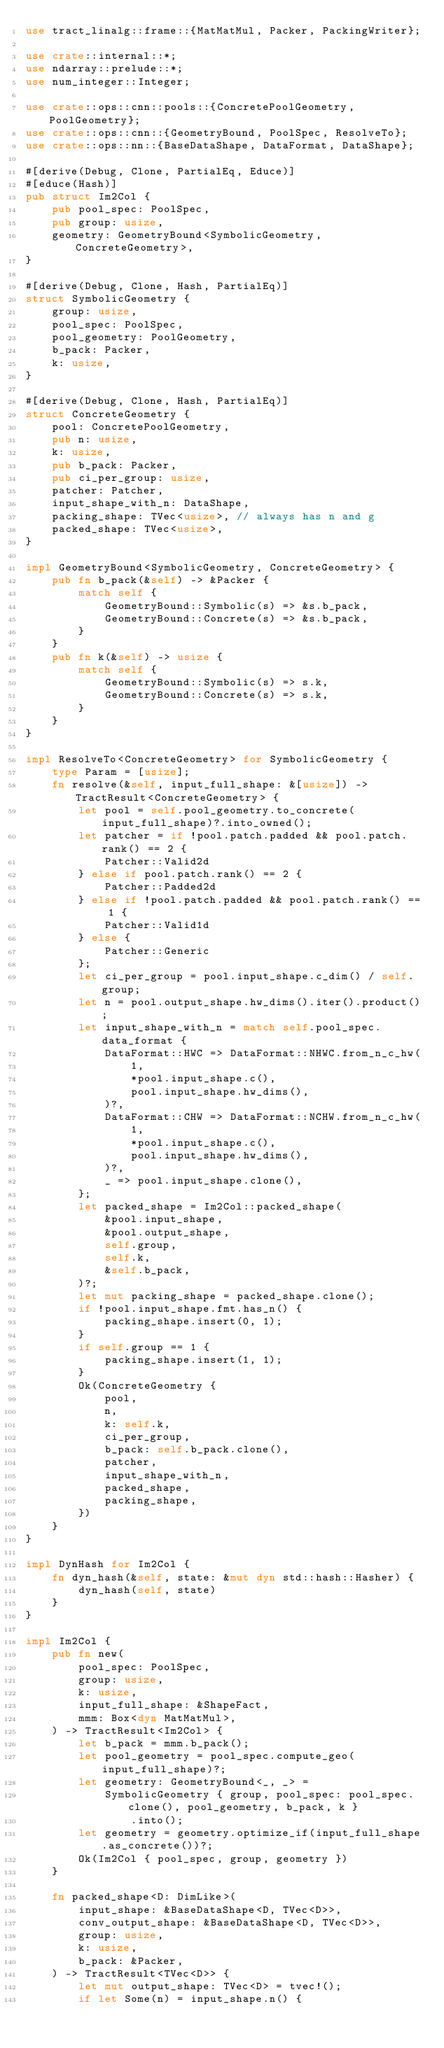Convert code to text. <code><loc_0><loc_0><loc_500><loc_500><_Rust_>use tract_linalg::frame::{MatMatMul, Packer, PackingWriter};

use crate::internal::*;
use ndarray::prelude::*;
use num_integer::Integer;

use crate::ops::cnn::pools::{ConcretePoolGeometry, PoolGeometry};
use crate::ops::cnn::{GeometryBound, PoolSpec, ResolveTo};
use crate::ops::nn::{BaseDataShape, DataFormat, DataShape};

#[derive(Debug, Clone, PartialEq, Educe)]
#[educe(Hash)]
pub struct Im2Col {
    pub pool_spec: PoolSpec,
    pub group: usize,
    geometry: GeometryBound<SymbolicGeometry, ConcreteGeometry>,
}

#[derive(Debug, Clone, Hash, PartialEq)]
struct SymbolicGeometry {
    group: usize,
    pool_spec: PoolSpec,
    pool_geometry: PoolGeometry,
    b_pack: Packer,
    k: usize,
}

#[derive(Debug, Clone, Hash, PartialEq)]
struct ConcreteGeometry {
    pool: ConcretePoolGeometry,
    pub n: usize,
    k: usize,
    pub b_pack: Packer,
    pub ci_per_group: usize,
    patcher: Patcher,
    input_shape_with_n: DataShape,
    packing_shape: TVec<usize>, // always has n and g
    packed_shape: TVec<usize>,
}

impl GeometryBound<SymbolicGeometry, ConcreteGeometry> {
    pub fn b_pack(&self) -> &Packer {
        match self {
            GeometryBound::Symbolic(s) => &s.b_pack,
            GeometryBound::Concrete(s) => &s.b_pack,
        }
    }
    pub fn k(&self) -> usize {
        match self {
            GeometryBound::Symbolic(s) => s.k,
            GeometryBound::Concrete(s) => s.k,
        }
    }
}

impl ResolveTo<ConcreteGeometry> for SymbolicGeometry {
    type Param = [usize];
    fn resolve(&self, input_full_shape: &[usize]) -> TractResult<ConcreteGeometry> {
        let pool = self.pool_geometry.to_concrete(input_full_shape)?.into_owned();
        let patcher = if !pool.patch.padded && pool.patch.rank() == 2 {
            Patcher::Valid2d
        } else if pool.patch.rank() == 2 {
            Patcher::Padded2d
        } else if !pool.patch.padded && pool.patch.rank() == 1 {
            Patcher::Valid1d
        } else {
            Patcher::Generic
        };
        let ci_per_group = pool.input_shape.c_dim() / self.group;
        let n = pool.output_shape.hw_dims().iter().product();
        let input_shape_with_n = match self.pool_spec.data_format {
            DataFormat::HWC => DataFormat::NHWC.from_n_c_hw(
                1,
                *pool.input_shape.c(),
                pool.input_shape.hw_dims(),
            )?,
            DataFormat::CHW => DataFormat::NCHW.from_n_c_hw(
                1,
                *pool.input_shape.c(),
                pool.input_shape.hw_dims(),
            )?,
            _ => pool.input_shape.clone(),
        };
        let packed_shape = Im2Col::packed_shape(
            &pool.input_shape,
            &pool.output_shape,
            self.group,
            self.k,
            &self.b_pack,
        )?;
        let mut packing_shape = packed_shape.clone();
        if !pool.input_shape.fmt.has_n() {
            packing_shape.insert(0, 1);
        }
        if self.group == 1 {
            packing_shape.insert(1, 1);
        }
        Ok(ConcreteGeometry {
            pool,
            n,
            k: self.k,
            ci_per_group,
            b_pack: self.b_pack.clone(),
            patcher,
            input_shape_with_n,
            packed_shape,
            packing_shape,
        })
    }
}

impl DynHash for Im2Col {
    fn dyn_hash(&self, state: &mut dyn std::hash::Hasher) {
        dyn_hash(self, state)
    }
}

impl Im2Col {
    pub fn new(
        pool_spec: PoolSpec,
        group: usize,
        k: usize,
        input_full_shape: &ShapeFact,
        mmm: Box<dyn MatMatMul>,
    ) -> TractResult<Im2Col> {
        let b_pack = mmm.b_pack();
        let pool_geometry = pool_spec.compute_geo(input_full_shape)?;
        let geometry: GeometryBound<_, _> =
            SymbolicGeometry { group, pool_spec: pool_spec.clone(), pool_geometry, b_pack, k }
                .into();
        let geometry = geometry.optimize_if(input_full_shape.as_concrete())?;
        Ok(Im2Col { pool_spec, group, geometry })
    }

    fn packed_shape<D: DimLike>(
        input_shape: &BaseDataShape<D, TVec<D>>,
        conv_output_shape: &BaseDataShape<D, TVec<D>>,
        group: usize,
        k: usize,
        b_pack: &Packer,
    ) -> TractResult<TVec<D>> {
        let mut output_shape: TVec<D> = tvec!();
        if let Some(n) = input_shape.n() {</code> 